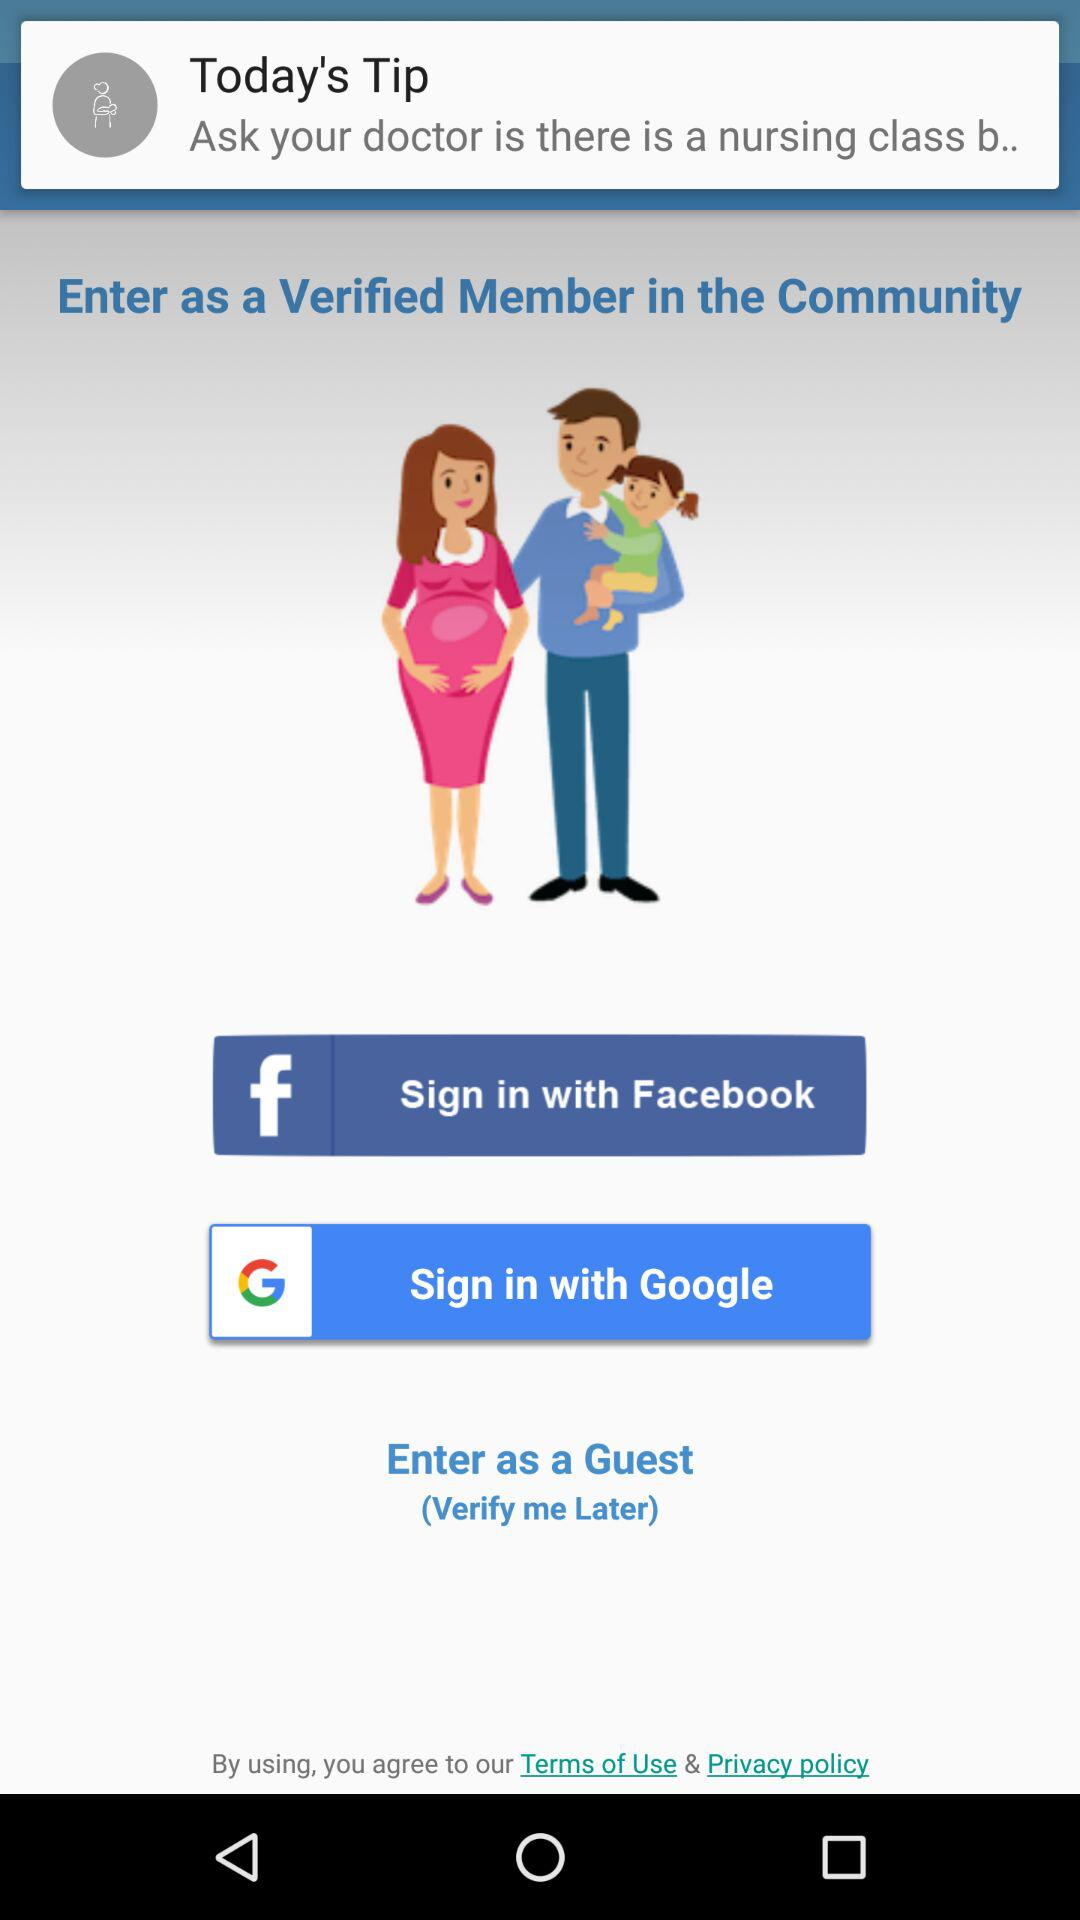How many options are there to sign in?
Answer the question using a single word or phrase. 3 